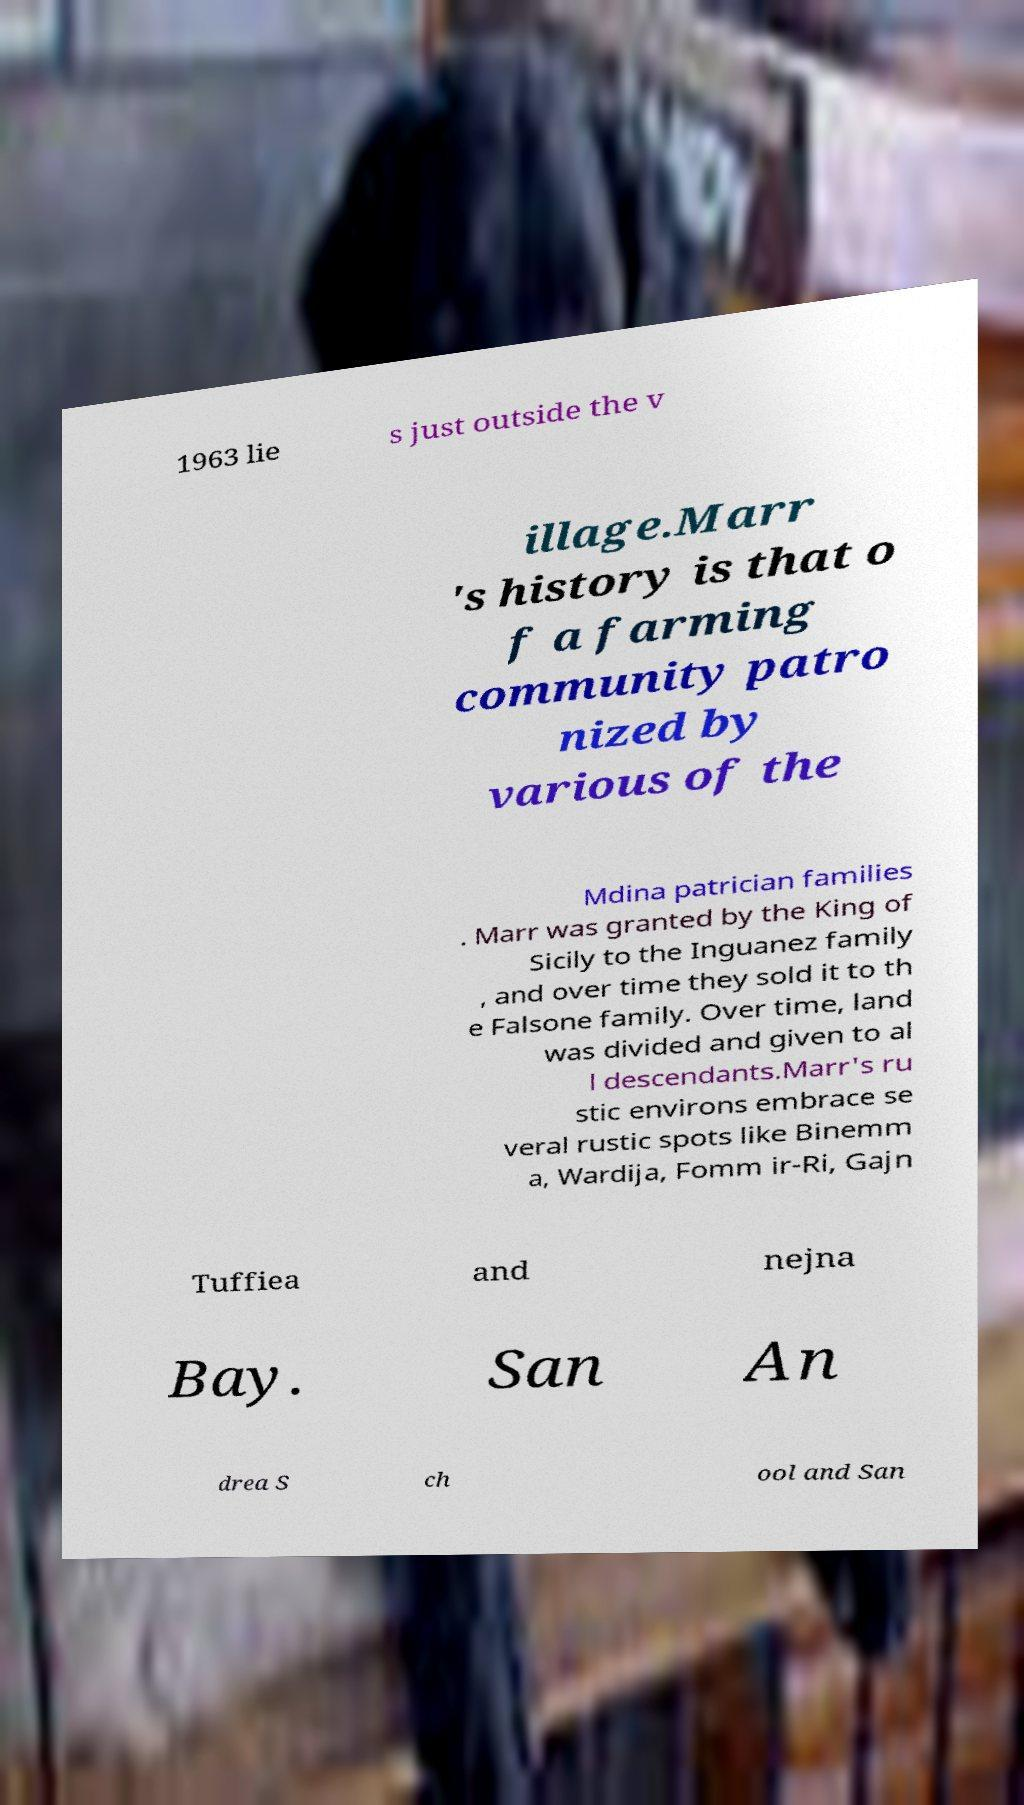Could you assist in decoding the text presented in this image and type it out clearly? 1963 lie s just outside the v illage.Marr 's history is that o f a farming community patro nized by various of the Mdina patrician families . Marr was granted by the King of Sicily to the Inguanez family , and over time they sold it to th e Falsone family. Over time, land was divided and given to al l descendants.Marr's ru stic environs embrace se veral rustic spots like Binemm a, Wardija, Fomm ir-Ri, Gajn Tuffiea and nejna Bay. San An drea S ch ool and San 